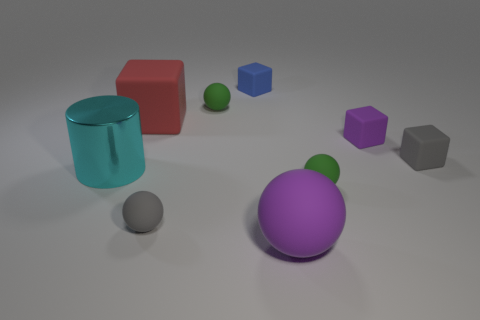Add 1 big cyan cylinders. How many objects exist? 10 Subtract all cylinders. How many objects are left? 8 Add 4 tiny yellow cubes. How many tiny yellow cubes exist? 4 Subtract 0 cyan blocks. How many objects are left? 9 Subtract all big brown metal cubes. Subtract all big red matte objects. How many objects are left? 8 Add 6 tiny gray rubber things. How many tiny gray rubber things are left? 8 